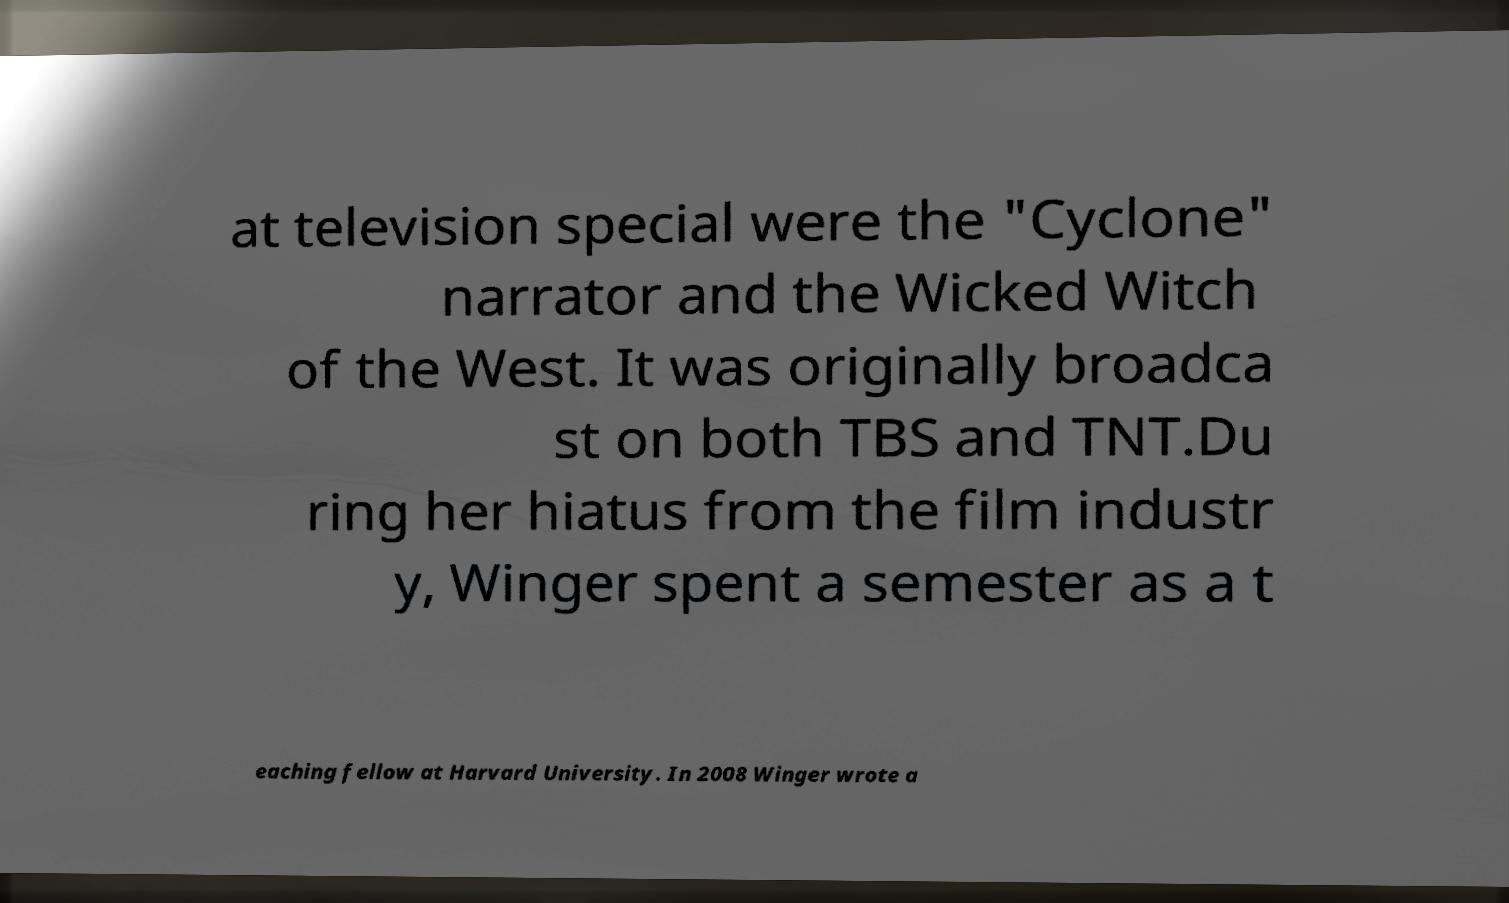Could you extract and type out the text from this image? at television special were the "Cyclone" narrator and the Wicked Witch of the West. It was originally broadca st on both TBS and TNT.Du ring her hiatus from the film industr y, Winger spent a semester as a t eaching fellow at Harvard University. In 2008 Winger wrote a 